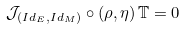Convert formula to latex. <formula><loc_0><loc_0><loc_500><loc_500>\mathcal { J } _ { \left ( I d _ { E } , I d _ { M } \right ) } \circ \left ( \rho , \eta \right ) \mathbb { T } = 0</formula> 